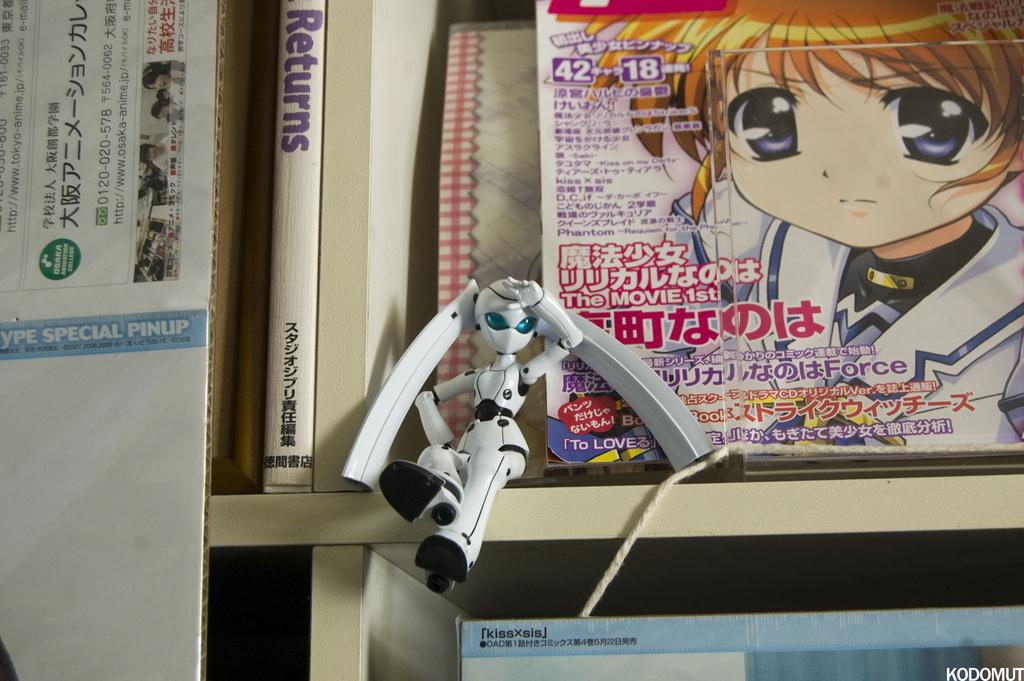<image>
Render a clear and concise summary of the photo. A magazine on a white shelf close to a book with the word "Returns" on it. 